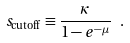Convert formula to latex. <formula><loc_0><loc_0><loc_500><loc_500>s _ { \text {cutoff} } \equiv \frac { \kappa } { 1 - e ^ { - \mu } } \ .</formula> 